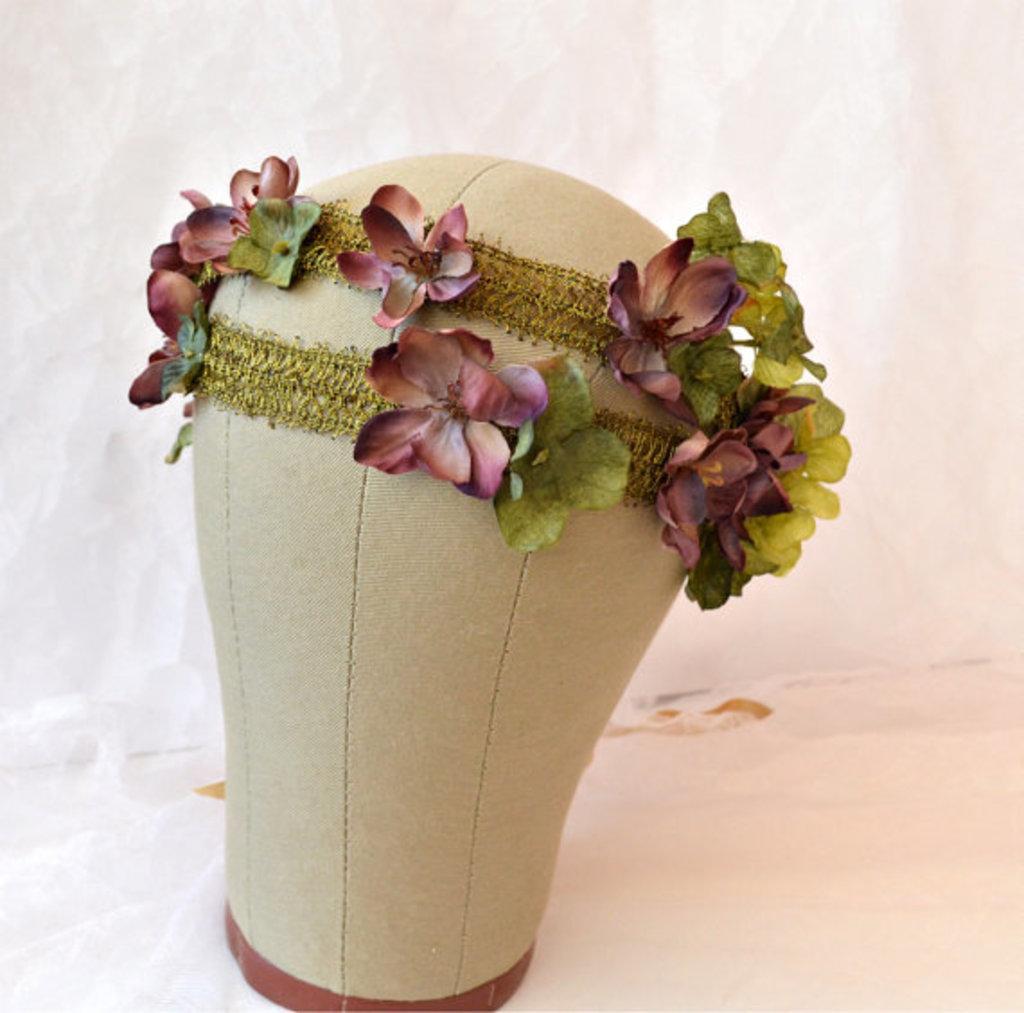Could you give a brief overview of what you see in this image? In this image we can see an object on the surface which is decorated with some flowers. 